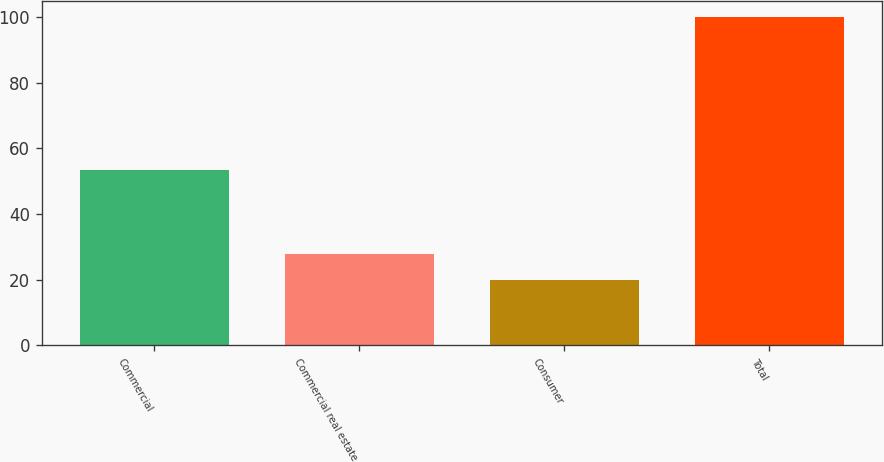<chart> <loc_0><loc_0><loc_500><loc_500><bar_chart><fcel>Commercial<fcel>Commercial real estate<fcel>Consumer<fcel>Total<nl><fcel>53.5<fcel>27.91<fcel>19.9<fcel>100<nl></chart> 